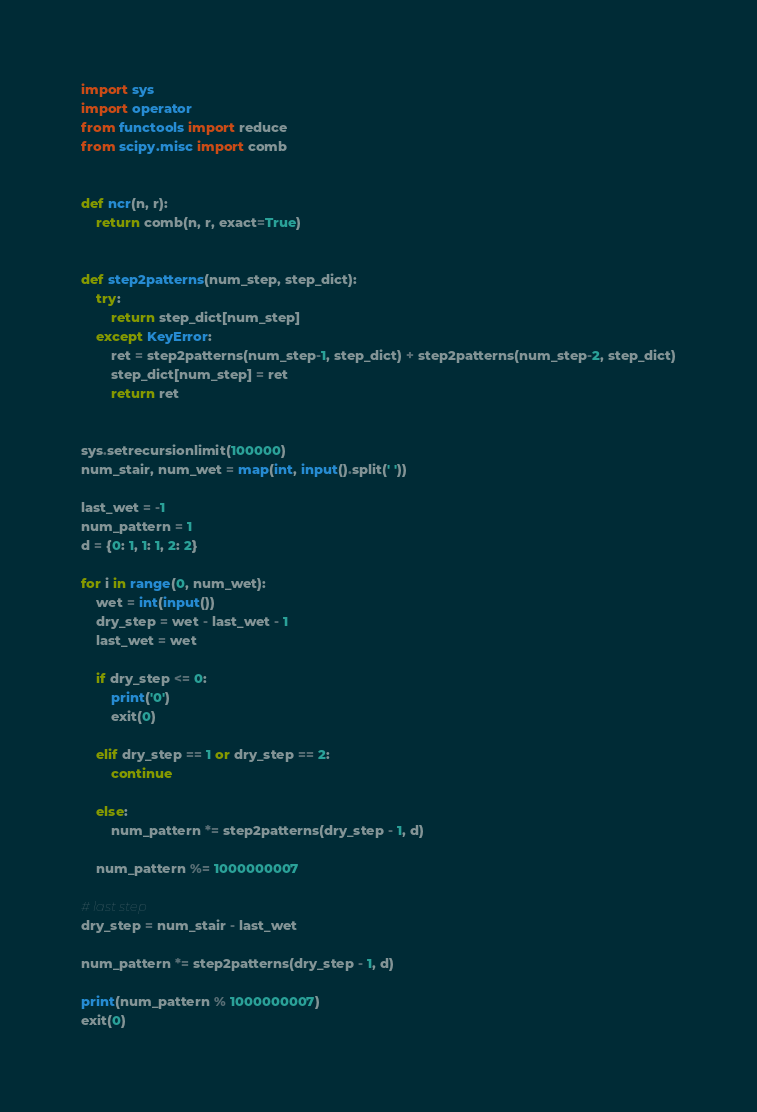Convert code to text. <code><loc_0><loc_0><loc_500><loc_500><_Python_>import sys
import operator
from functools import reduce
from scipy.misc import comb


def ncr(n, r):
    return comb(n, r, exact=True)


def step2patterns(num_step, step_dict):
    try:
        return step_dict[num_step]
    except KeyError:
        ret = step2patterns(num_step-1, step_dict) + step2patterns(num_step-2, step_dict)
        step_dict[num_step] = ret
        return ret


sys.setrecursionlimit(100000)
num_stair, num_wet = map(int, input().split(' '))

last_wet = -1
num_pattern = 1
d = {0: 1, 1: 1, 2: 2}

for i in range(0, num_wet):
    wet = int(input())
    dry_step = wet - last_wet - 1
    last_wet = wet

    if dry_step <= 0:
        print('0')
        exit(0)

    elif dry_step == 1 or dry_step == 2:
        continue

    else:
        num_pattern *= step2patterns(dry_step - 1, d)

    num_pattern %= 1000000007

# last step
dry_step = num_stair - last_wet

num_pattern *= step2patterns(dry_step - 1, d)

print(num_pattern % 1000000007)
exit(0)
</code> 